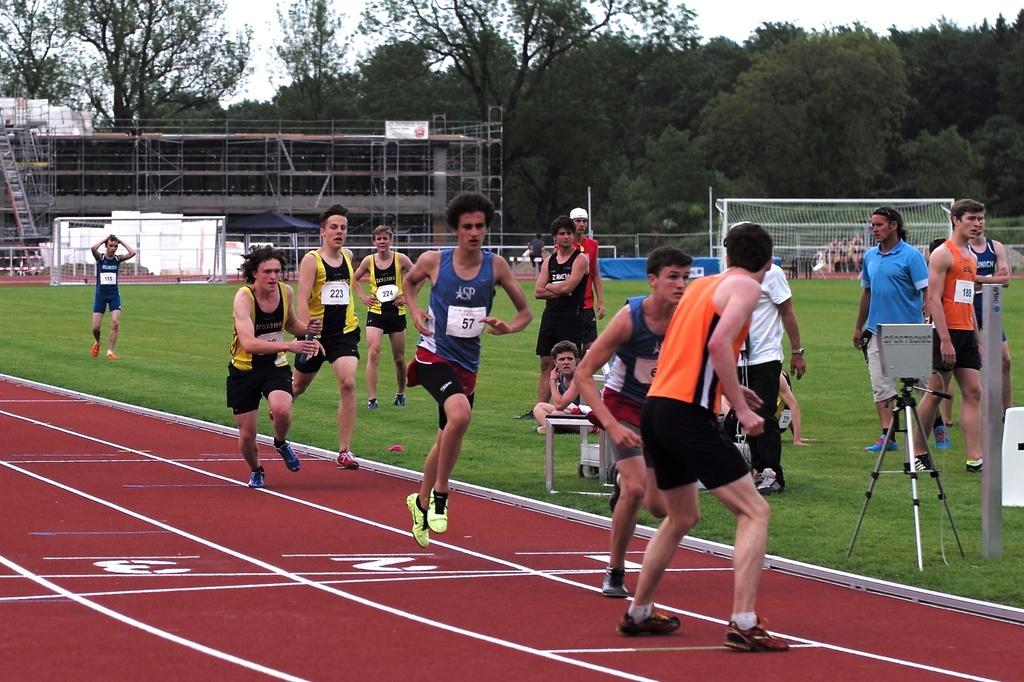What are the people in the image doing? The people in the image are running. What can be seen on the right side of the image? There is a stand on the right side of the image. What is present in the image besides the people running? There is a table in the image. What is visible in the background of the image? There is a net, a building, trees, and the sky visible in the background of the image. Can you tell me where the monkey is hiding in the image? There is no monkey present in the image. What type of locket is hanging from the net in the image? There is no locket present in the image; only a net is visible in the background. 